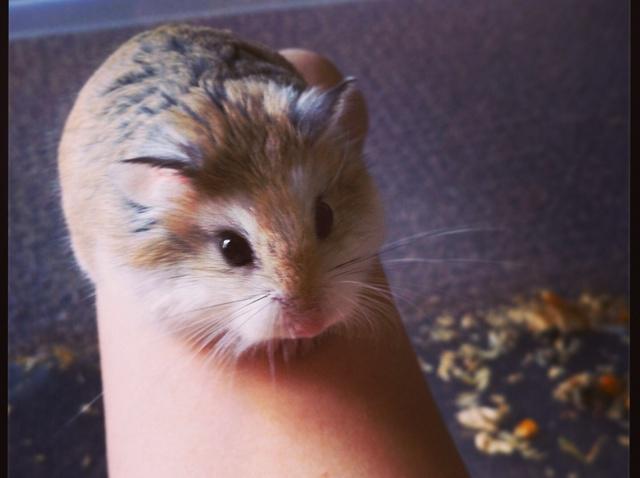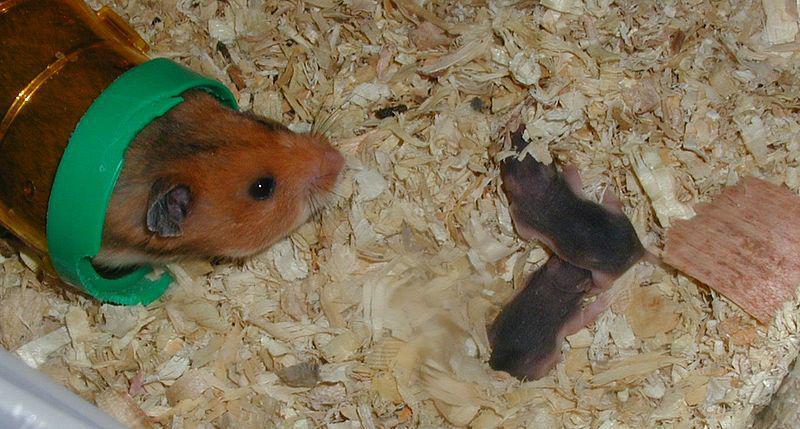The first image is the image on the left, the second image is the image on the right. For the images shown, is this caption "An image shows one adult rodent with more than one newborn nearby." true? Answer yes or no. Yes. The first image is the image on the left, the second image is the image on the right. Given the left and right images, does the statement "There are at least two newborn rodents." hold true? Answer yes or no. Yes. 